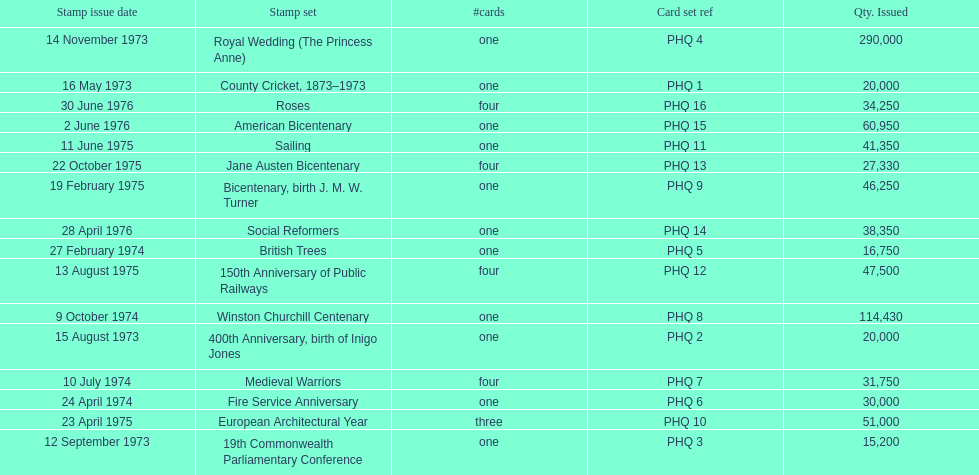Which card was issued most? Royal Wedding (The Princess Anne). 